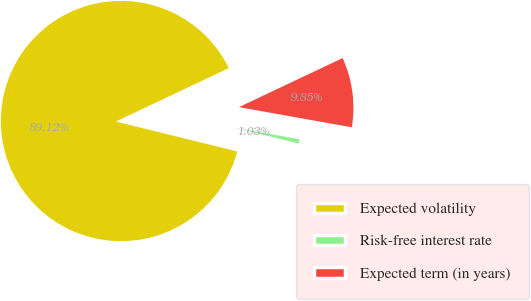<chart> <loc_0><loc_0><loc_500><loc_500><pie_chart><fcel>Expected volatility<fcel>Risk-free interest rate<fcel>Expected term (in years)<nl><fcel>89.12%<fcel>1.03%<fcel>9.85%<nl></chart> 